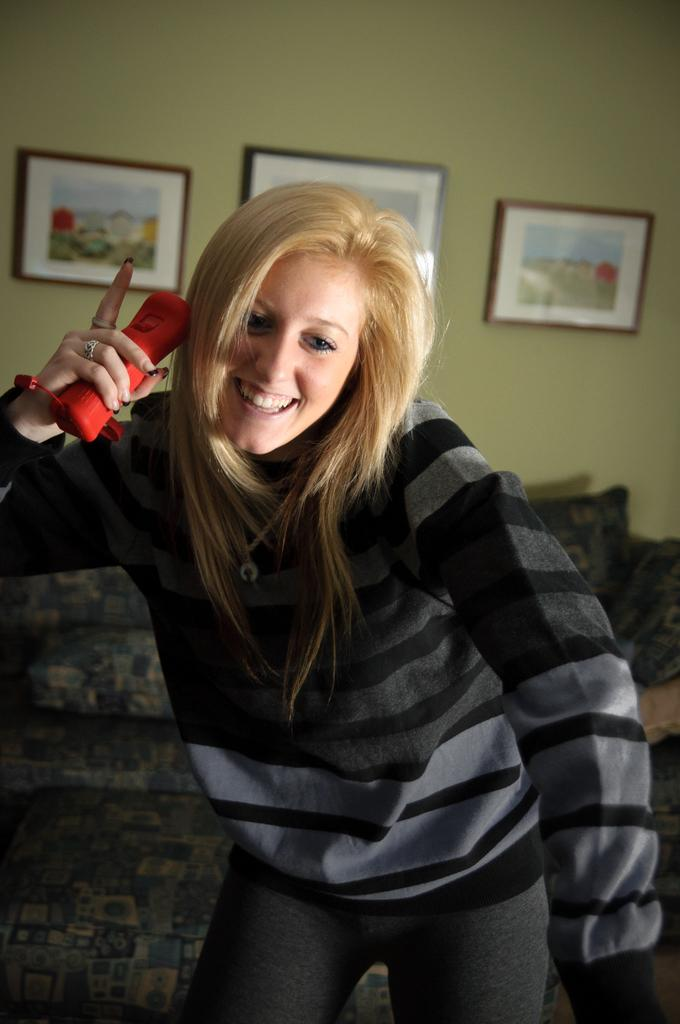Who is present in the image? There is a woman in the image. What is the woman holding in the image? The woman is holding a red object. What is the woman's facial expression in the image? The woman is smiling in the image. What can be seen in the background of the image? There is a couch, cushions, a wall, and photo frames on the wall in the background of the image. What type of building can be seen in the image? There is no building present in the image. How does the woman start learning in the image? The image does not depict the woman learning or any related activity. 